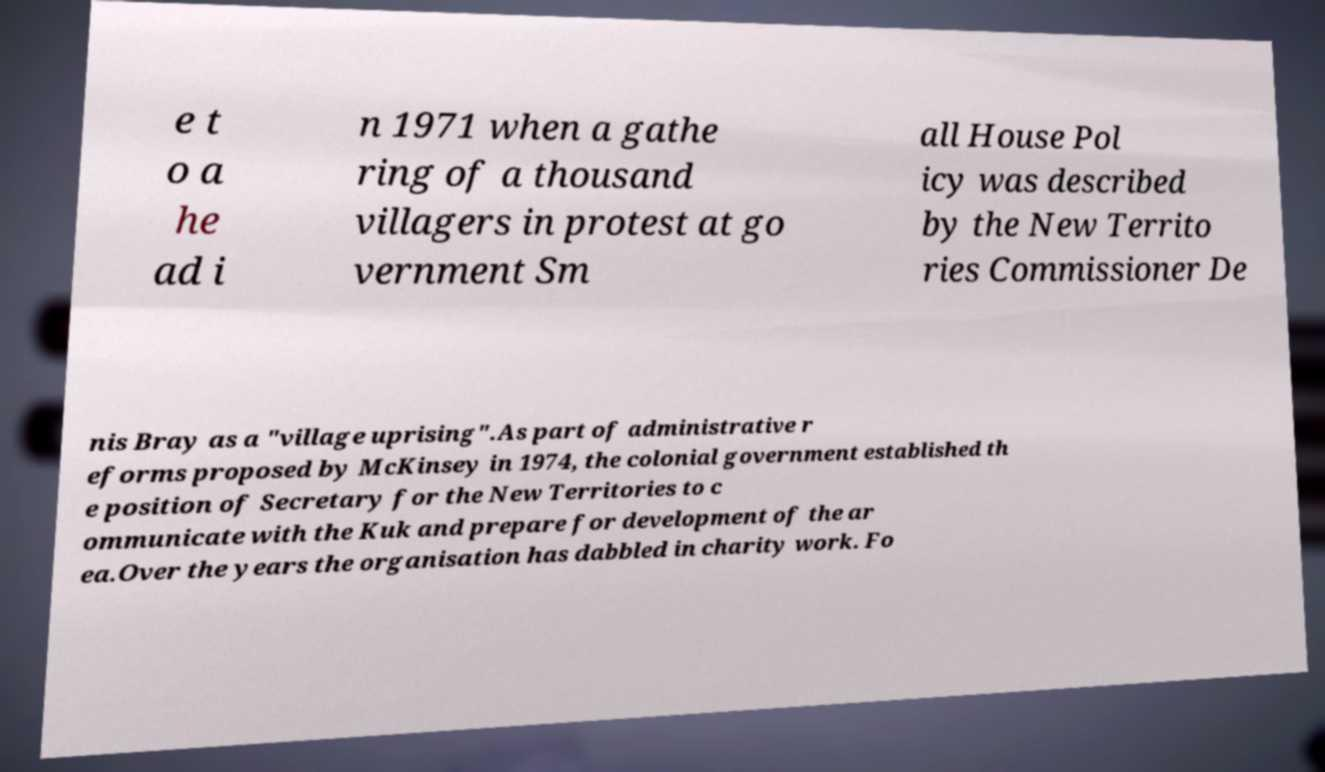Please identify and transcribe the text found in this image. e t o a he ad i n 1971 when a gathe ring of a thousand villagers in protest at go vernment Sm all House Pol icy was described by the New Territo ries Commissioner De nis Bray as a "village uprising".As part of administrative r eforms proposed by McKinsey in 1974, the colonial government established th e position of Secretary for the New Territories to c ommunicate with the Kuk and prepare for development of the ar ea.Over the years the organisation has dabbled in charity work. Fo 